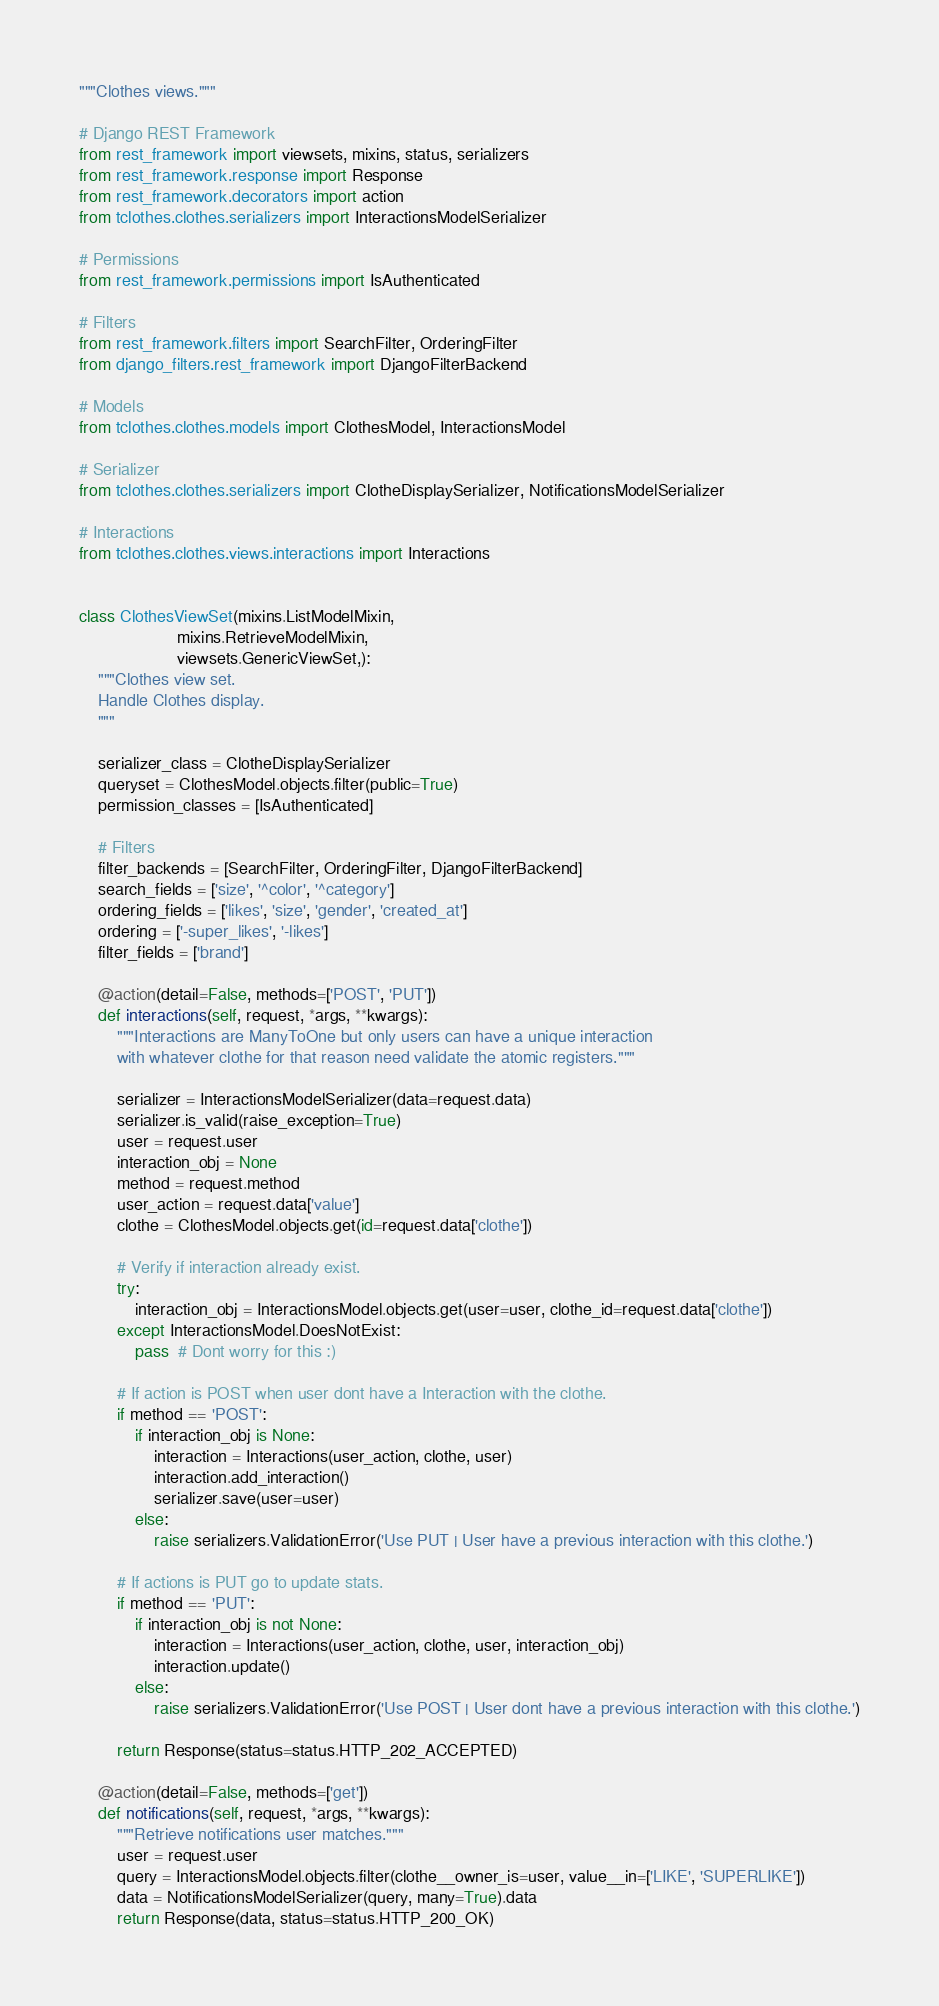Convert code to text. <code><loc_0><loc_0><loc_500><loc_500><_Python_>"""Clothes views."""

# Django REST Framework
from rest_framework import viewsets, mixins, status, serializers
from rest_framework.response import Response
from rest_framework.decorators import action
from tclothes.clothes.serializers import InteractionsModelSerializer

# Permissions
from rest_framework.permissions import IsAuthenticated

# Filters
from rest_framework.filters import SearchFilter, OrderingFilter
from django_filters.rest_framework import DjangoFilterBackend

# Models
from tclothes.clothes.models import ClothesModel, InteractionsModel

# Serializer
from tclothes.clothes.serializers import ClotheDisplaySerializer, NotificationsModelSerializer

# Interactions
from tclothes.clothes.views.interactions import Interactions


class ClothesViewSet(mixins.ListModelMixin,
                     mixins.RetrieveModelMixin,
                     viewsets.GenericViewSet,):
    """Clothes view set.
    Handle Clothes display.
    """

    serializer_class = ClotheDisplaySerializer
    queryset = ClothesModel.objects.filter(public=True)
    permission_classes = [IsAuthenticated]

    # Filters
    filter_backends = [SearchFilter, OrderingFilter, DjangoFilterBackend]
    search_fields = ['size', '^color', '^category']
    ordering_fields = ['likes', 'size', 'gender', 'created_at']
    ordering = ['-super_likes', '-likes']
    filter_fields = ['brand']

    @action(detail=False, methods=['POST', 'PUT'])
    def interactions(self, request, *args, **kwargs):
        """Interactions are ManyToOne but only users can have a unique interaction
        with whatever clothe for that reason need validate the atomic registers."""

        serializer = InteractionsModelSerializer(data=request.data)
        serializer.is_valid(raise_exception=True)
        user = request.user
        interaction_obj = None
        method = request.method
        user_action = request.data['value']
        clothe = ClothesModel.objects.get(id=request.data['clothe'])

        # Verify if interaction already exist.
        try:
            interaction_obj = InteractionsModel.objects.get(user=user, clothe_id=request.data['clothe'])
        except InteractionsModel.DoesNotExist:
            pass  # Dont worry for this :)

        # If action is POST when user dont have a Interaction with the clothe.
        if method == 'POST':
            if interaction_obj is None:
                interaction = Interactions(user_action, clothe, user)
                interaction.add_interaction()
                serializer.save(user=user)
            else:
                raise serializers.ValidationError('Use PUT | User have a previous interaction with this clothe.')

        # If actions is PUT go to update stats.
        if method == 'PUT':
            if interaction_obj is not None:
                interaction = Interactions(user_action, clothe, user, interaction_obj)
                interaction.update()
            else:
                raise serializers.ValidationError('Use POST | User dont have a previous interaction with this clothe.')

        return Response(status=status.HTTP_202_ACCEPTED)

    @action(detail=False, methods=['get'])
    def notifications(self, request, *args, **kwargs):
        """Retrieve notifications user matches."""
        user = request.user
        query = InteractionsModel.objects.filter(clothe__owner_is=user, value__in=['LIKE', 'SUPERLIKE'])
        data = NotificationsModelSerializer(query, many=True).data
        return Response(data, status=status.HTTP_200_OK)
</code> 